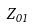Convert formula to latex. <formula><loc_0><loc_0><loc_500><loc_500>Z _ { 0 1 }</formula> 